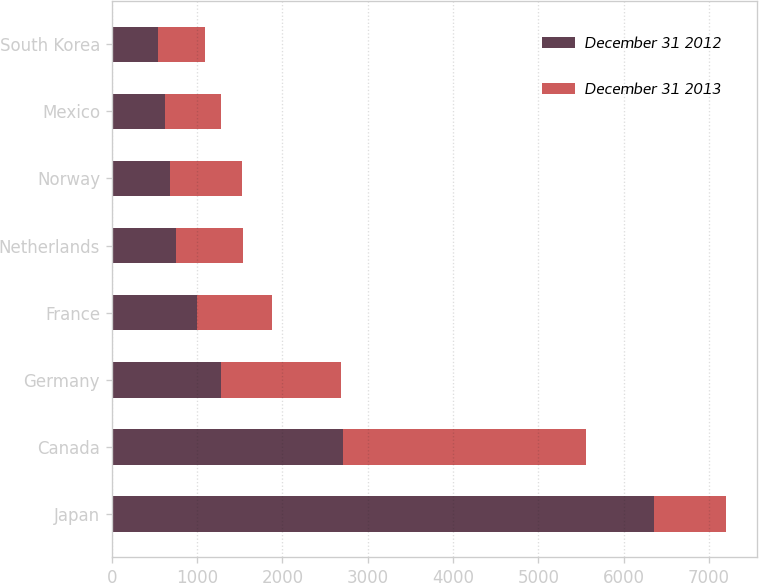Convert chart. <chart><loc_0><loc_0><loc_500><loc_500><stacked_bar_chart><ecel><fcel>Japan<fcel>Canada<fcel>Germany<fcel>France<fcel>Netherlands<fcel>Norway<fcel>Mexico<fcel>South Korea<nl><fcel>December 31 2012<fcel>6350<fcel>2714<fcel>1281<fcel>1005<fcel>759<fcel>682<fcel>622<fcel>538<nl><fcel>December 31 2013<fcel>850<fcel>2841<fcel>1408<fcel>876<fcel>778<fcel>850<fcel>655<fcel>552<nl></chart> 